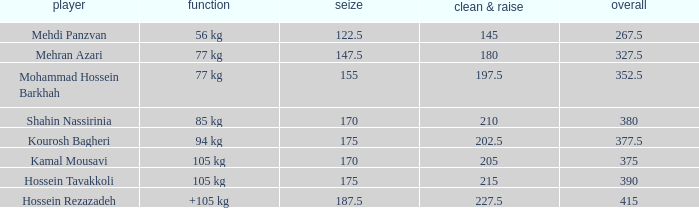What is the lowest total that had less than 170 snatches, 56 kg events and less than 145 clean & jerk? None. 